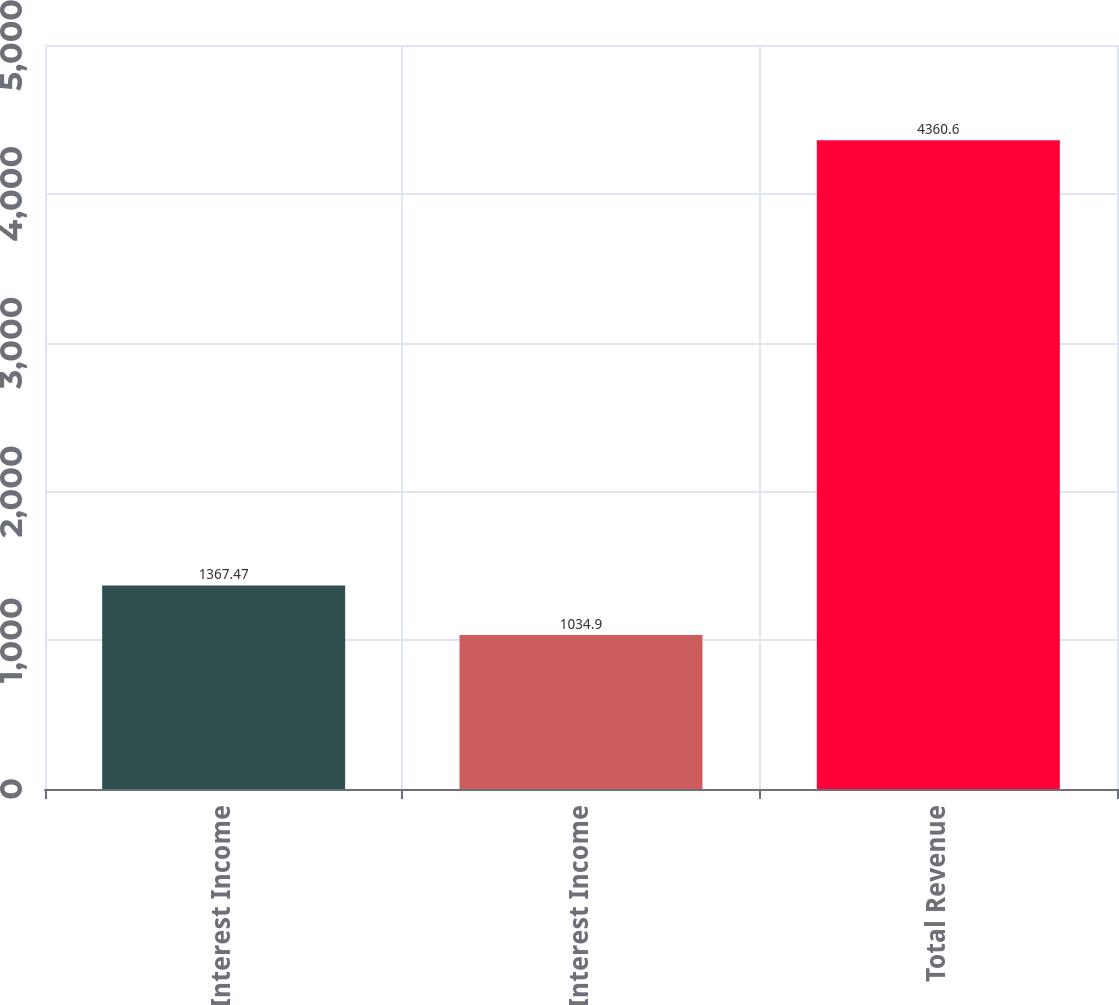Convert chart to OTSL. <chart><loc_0><loc_0><loc_500><loc_500><bar_chart><fcel>Interest Income<fcel>Net Interest Income<fcel>Total Revenue<nl><fcel>1367.47<fcel>1034.9<fcel>4360.6<nl></chart> 